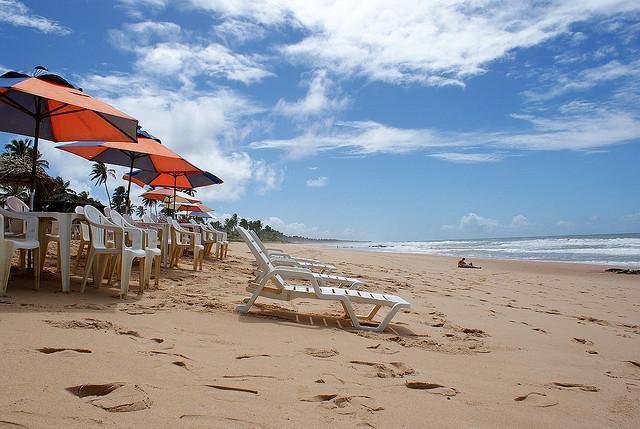How many chairs are in the picture?
Give a very brief answer. 3. How many umbrellas are visible?
Give a very brief answer. 2. 